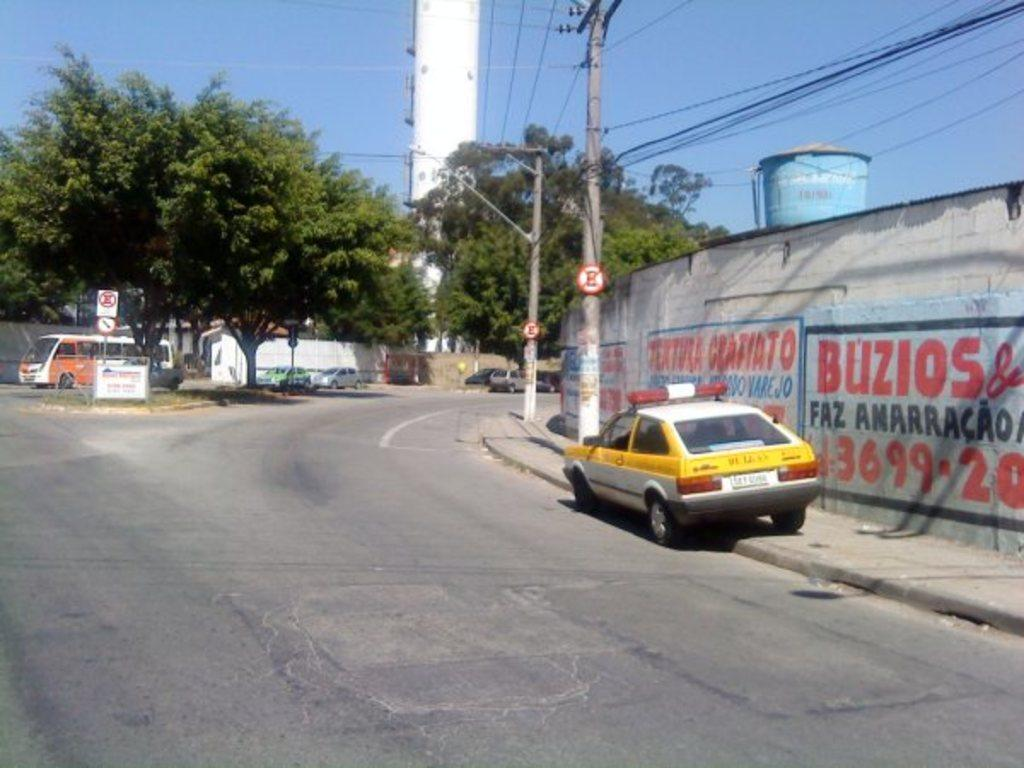<image>
Relay a brief, clear account of the picture shown. The white sign with the black border has the numbers 3699 written in red. 